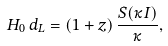<formula> <loc_0><loc_0><loc_500><loc_500>H _ { 0 } \, d _ { L } = ( 1 + z ) \, \frac { S ( \kappa I ) } { \kappa } ,</formula> 